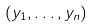Convert formula to latex. <formula><loc_0><loc_0><loc_500><loc_500>( y _ { 1 } , \dots , y _ { n } )</formula> 